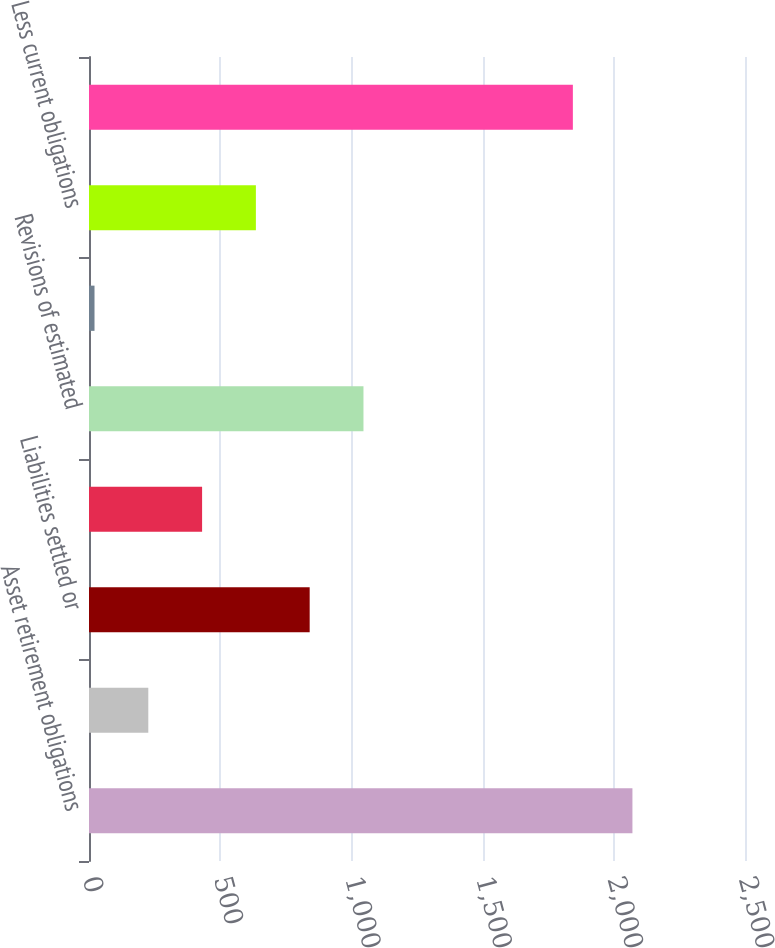Convert chart. <chart><loc_0><loc_0><loc_500><loc_500><bar_chart><fcel>Asset retirement obligations<fcel>Liabilities incurred<fcel>Liabilities settled or<fcel>Accretion expense<fcel>Revisions of estimated<fcel>Foreign currency translation<fcel>Less current obligations<fcel>Long-term obligations at<nl><fcel>2071<fcel>226<fcel>841<fcel>431<fcel>1046<fcel>21<fcel>636<fcel>1844<nl></chart> 